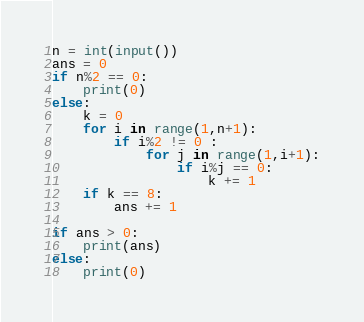Convert code to text. <code><loc_0><loc_0><loc_500><loc_500><_Python_>n = int(input())
ans = 0
if n%2 == 0:
    print(0)
else:
    k = 0
    for i in range(1,n+1):
        if i%2 != 0 :
            for j in range(1,i+1):
                if i%j == 0:
                    k += 1
    if k == 8:
        ans += 1

if ans > 0:
    print(ans)
else:
    print(0)   </code> 